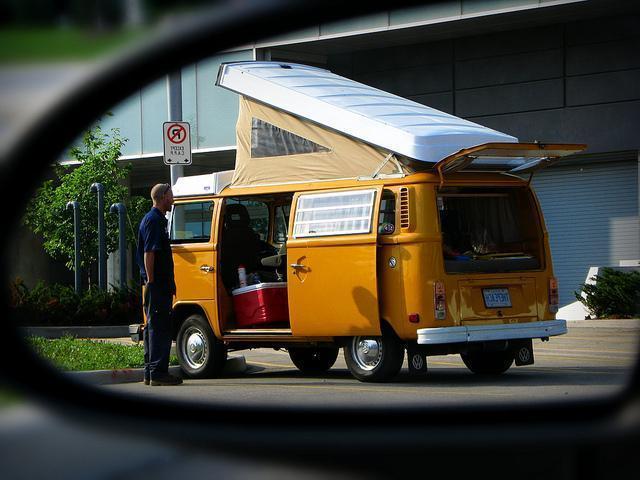Is the statement "The person is at the left side of the truck." accurate regarding the image?
Answer yes or no. Yes. 